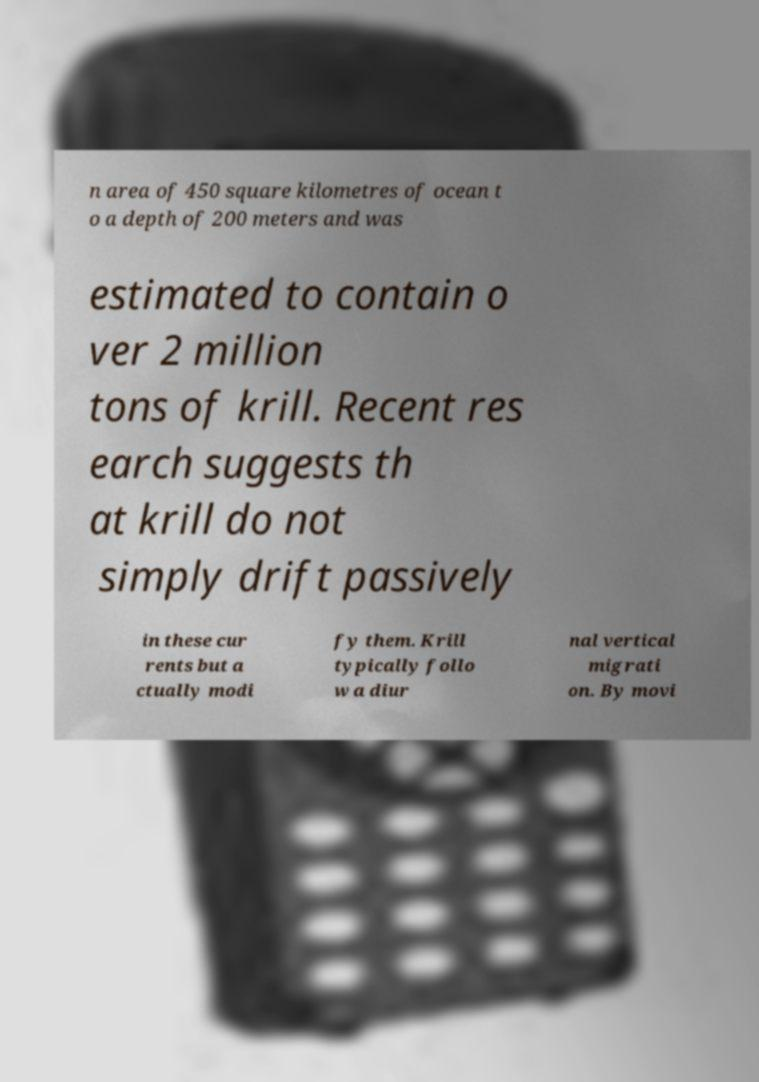Can you read and provide the text displayed in the image?This photo seems to have some interesting text. Can you extract and type it out for me? n area of 450 square kilometres of ocean t o a depth of 200 meters and was estimated to contain o ver 2 million tons of krill. Recent res earch suggests th at krill do not simply drift passively in these cur rents but a ctually modi fy them. Krill typically follo w a diur nal vertical migrati on. By movi 